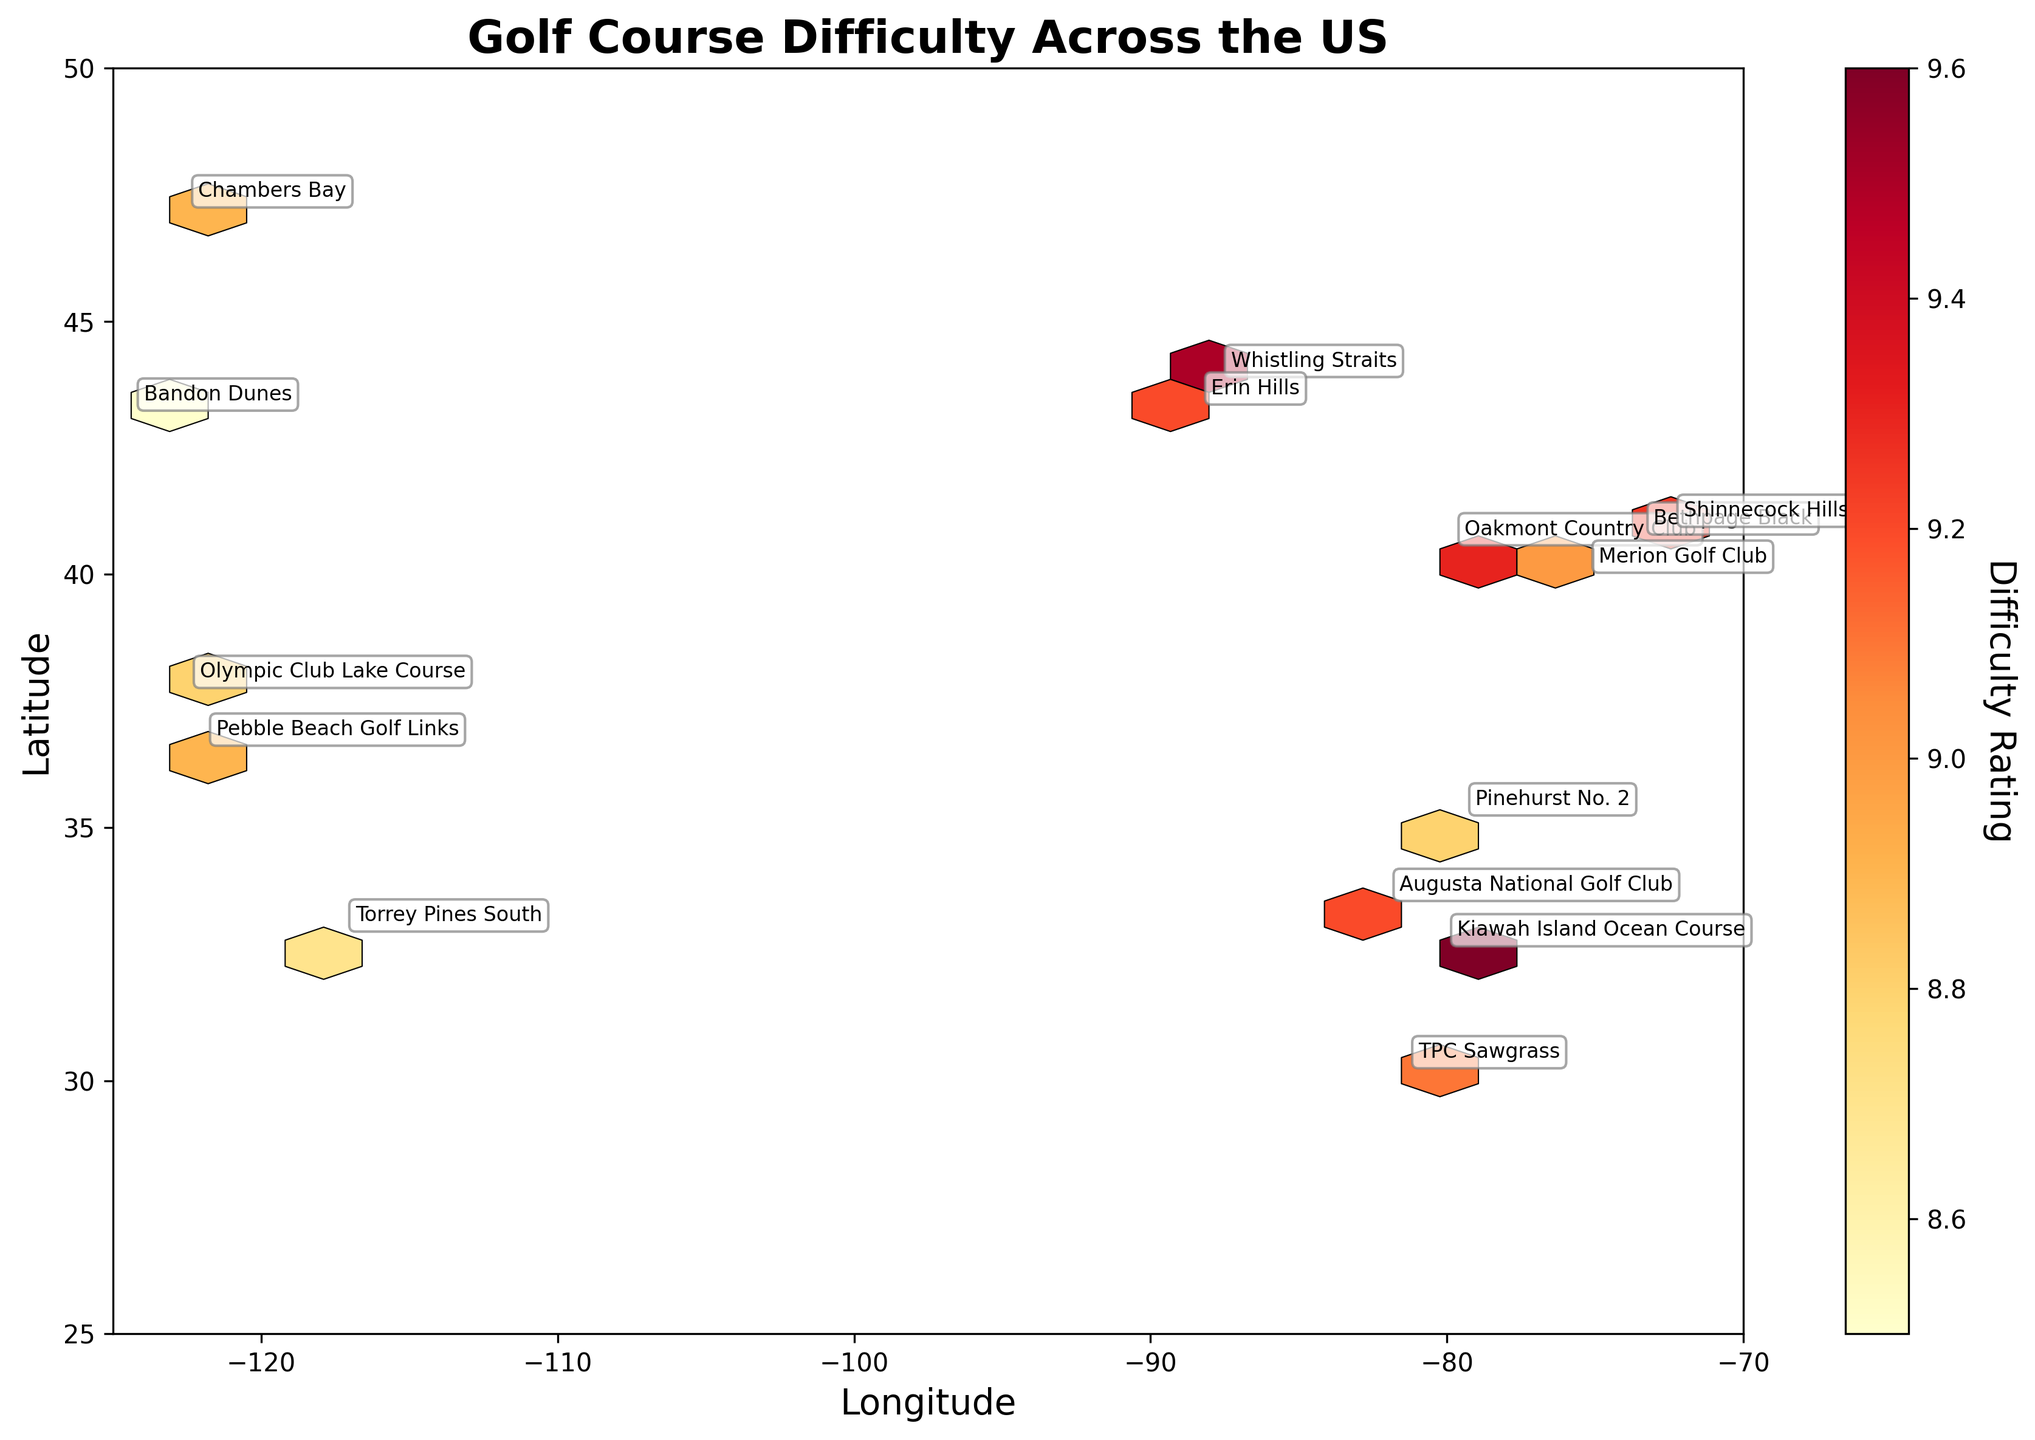How many golf courses are represented in the figure? To find the number of golf courses, count the individual data points or course names annotated on the plot. Each course name represents one golf course.
Answer: 15 What is the title of the plot? The title of the plot is written at the top of the figure and typically summarizes the content being displayed.
Answer: Golf Course Difficulty Across the US Which course is located at the most northern latitude? To find the most northern course, look for the highest latitude value on the vertical axis and identify the corresponding course name at that position.
Answer: Chambers Bay Which course has the highest difficulty rating and where is it located? Check the color intensity in the colorbar where higher ratings have distinct colors, then identify the corresponding course name and its latitude and longitude annotations in this color region.
Answer: Kiawah Island Ocean Course at latitude 32.6068 and longitude -80.0817 Which course has a similar difficulty rating to Pebble Beach Golf Links but located in a different state? Compare the color shade corresponding to the difficulty rating of Pebble Beach Golf Links with other courses, then check their names and locations.
Answer: Chambers Bay Is the slope rating correlated with the difficulty rating? Explain with examples from the plot. Check if courses with higher difficulty ratings typically have higher slope ratings by looking at the course annotations and cross-referencing their difficulty and slope ratings. Examples like TPC Sawgrass and Kiawah Island Ocean Course could be used.
Answer: Yes, courses with higher difficulty ratings often have higher slope ratings (e.g., TPC Sawgrass has high difficulty and slope, Kiawah Island Ocean Course has both at the maximum values) Which region of the US has the most clustered golf courses based on latitude and longitude? Observe the concentration of hexagons (hexes) in specific regions on the map and determine where most of them cluster.
Answer: The northeastern region Considering slope, par, and yardage, does a higher yardage usually indicate a greater difficulty rating? Compare the yardage and difficulty ratings of several courses to see if courses with greater yardage tend to have higher difficulty ratings. Courses like Whistling Straits (high yardage and difficulty) could be referenced.
Answer: Generally, yes (e.g., Whistling Straits and Kiawah Island Ocean Course have high yardage and ratings) 